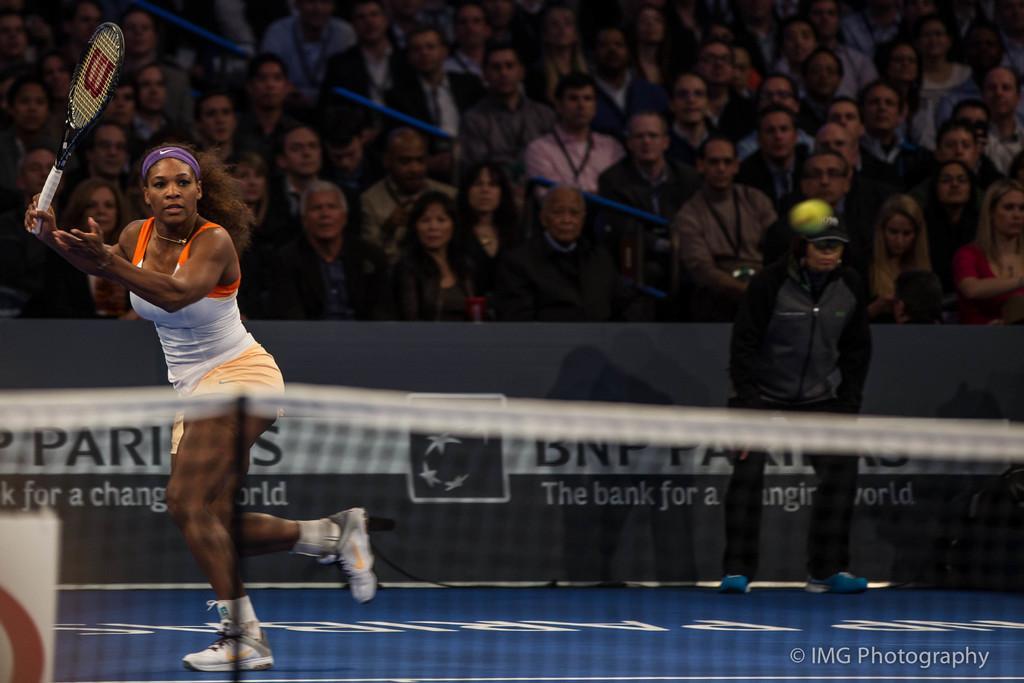Could you give a brief overview of what you see in this image? This picture shows a woman playing tennis with a racket and we see audience watching them and here we see a man standing called Empire 